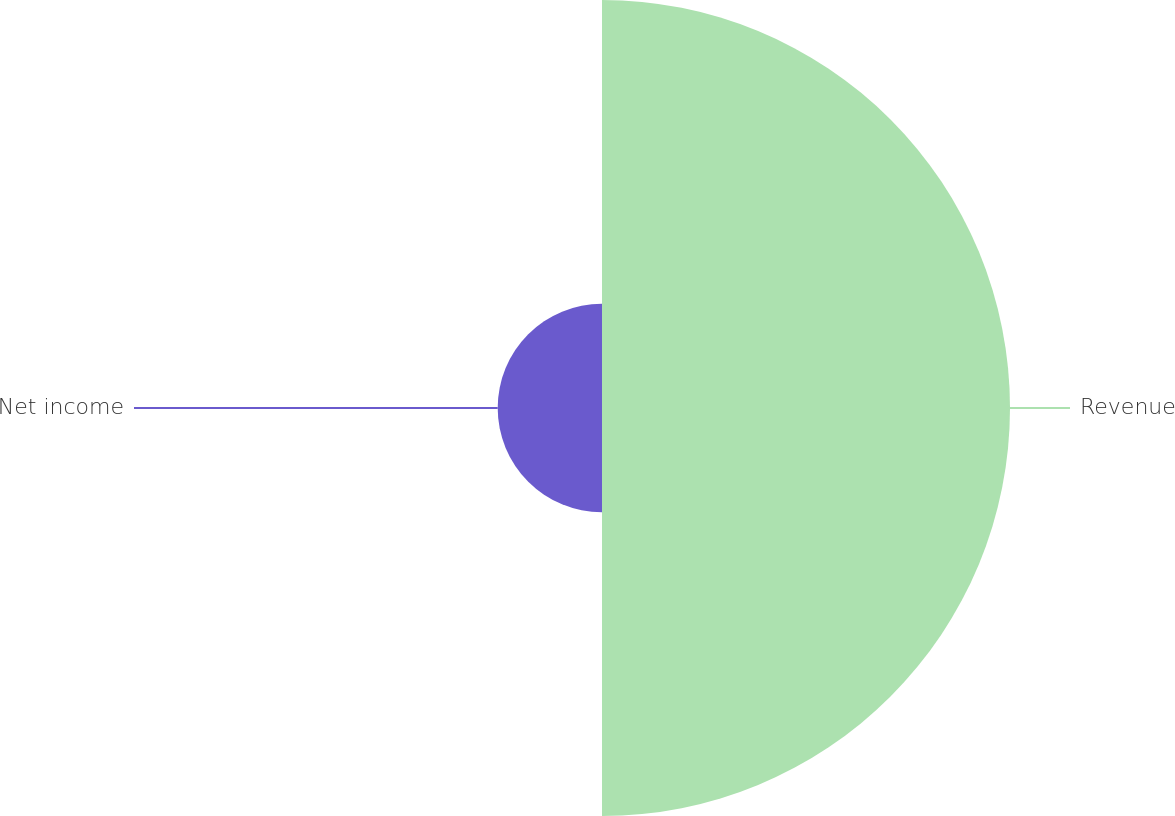Convert chart to OTSL. <chart><loc_0><loc_0><loc_500><loc_500><pie_chart><fcel>Revenue<fcel>Net income<nl><fcel>79.64%<fcel>20.36%<nl></chart> 